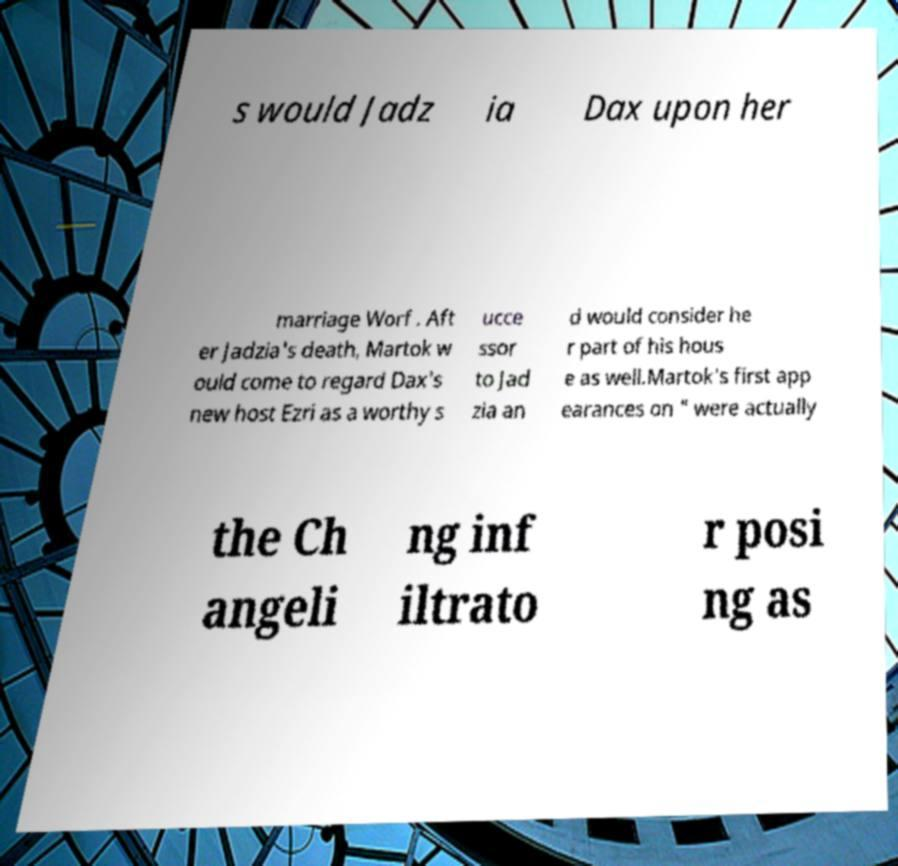Please read and relay the text visible in this image. What does it say? s would Jadz ia Dax upon her marriage Worf . Aft er Jadzia's death, Martok w ould come to regard Dax's new host Ezri as a worthy s ucce ssor to Jad zia an d would consider he r part of his hous e as well.Martok's first app earances on " were actually the Ch angeli ng inf iltrato r posi ng as 